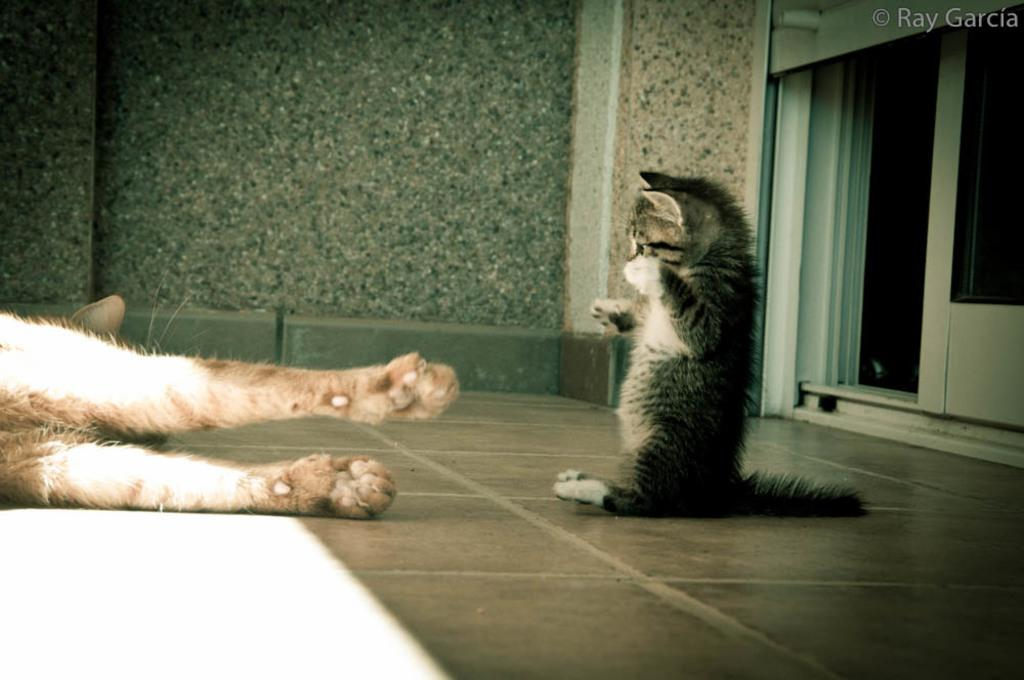What type of animal is sitting in the image? There is a cat sitting in the image. What is the other animal doing in the image? There is an animal lying on the floor in the image. What can be seen in the background of the image? There is a wall visible in the background of the image. How many tomatoes are on the roof in the image? There are no tomatoes or roof present in the image. What type of mark can be seen on the cat's fur in the image? There is no mention of any mark on the cat's fur in the provided facts. 